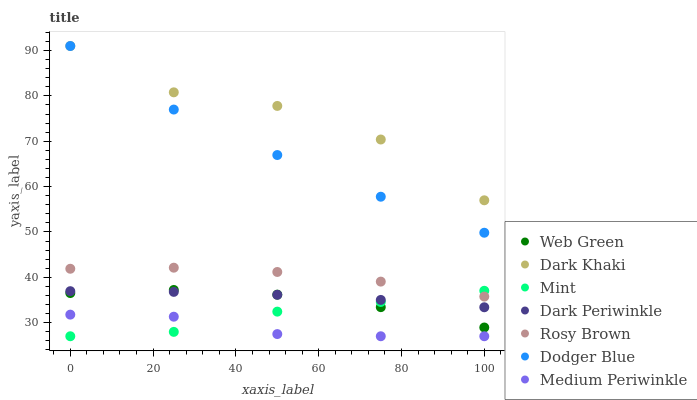Does Medium Periwinkle have the minimum area under the curve?
Answer yes or no. Yes. Does Dark Khaki have the maximum area under the curve?
Answer yes or no. Yes. Does Web Green have the minimum area under the curve?
Answer yes or no. No. Does Web Green have the maximum area under the curve?
Answer yes or no. No. Is Dark Periwinkle the smoothest?
Answer yes or no. Yes. Is Dark Khaki the roughest?
Answer yes or no. Yes. Is Medium Periwinkle the smoothest?
Answer yes or no. No. Is Medium Periwinkle the roughest?
Answer yes or no. No. Does Medium Periwinkle have the lowest value?
Answer yes or no. Yes. Does Web Green have the lowest value?
Answer yes or no. No. Does Dodger Blue have the highest value?
Answer yes or no. Yes. Does Web Green have the highest value?
Answer yes or no. No. Is Mint less than Dodger Blue?
Answer yes or no. Yes. Is Web Green greater than Medium Periwinkle?
Answer yes or no. Yes. Does Mint intersect Rosy Brown?
Answer yes or no. Yes. Is Mint less than Rosy Brown?
Answer yes or no. No. Is Mint greater than Rosy Brown?
Answer yes or no. No. Does Mint intersect Dodger Blue?
Answer yes or no. No. 